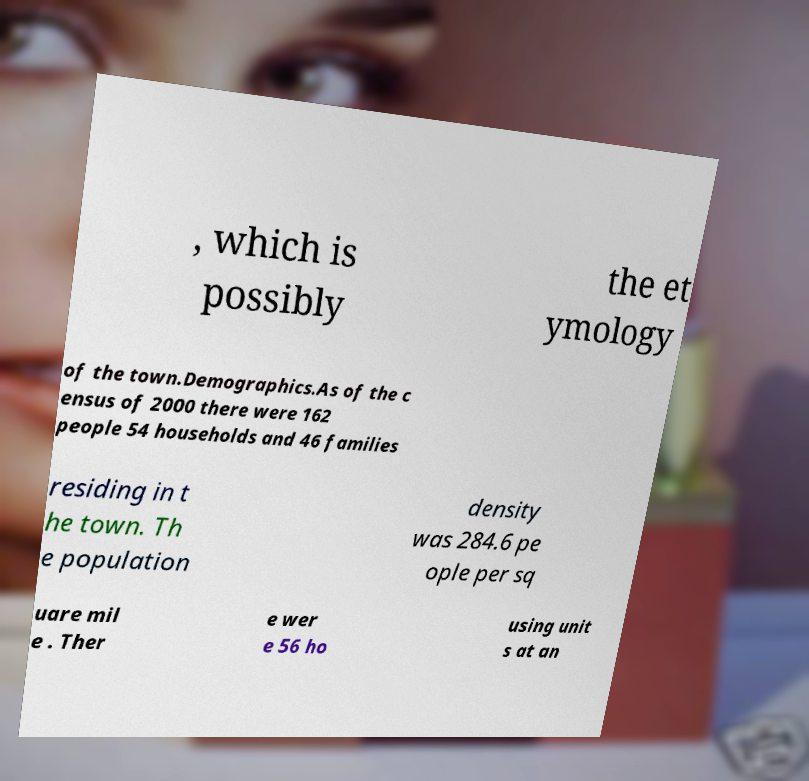Please identify and transcribe the text found in this image. , which is possibly the et ymology of the town.Demographics.As of the c ensus of 2000 there were 162 people 54 households and 46 families residing in t he town. Th e population density was 284.6 pe ople per sq uare mil e . Ther e wer e 56 ho using unit s at an 